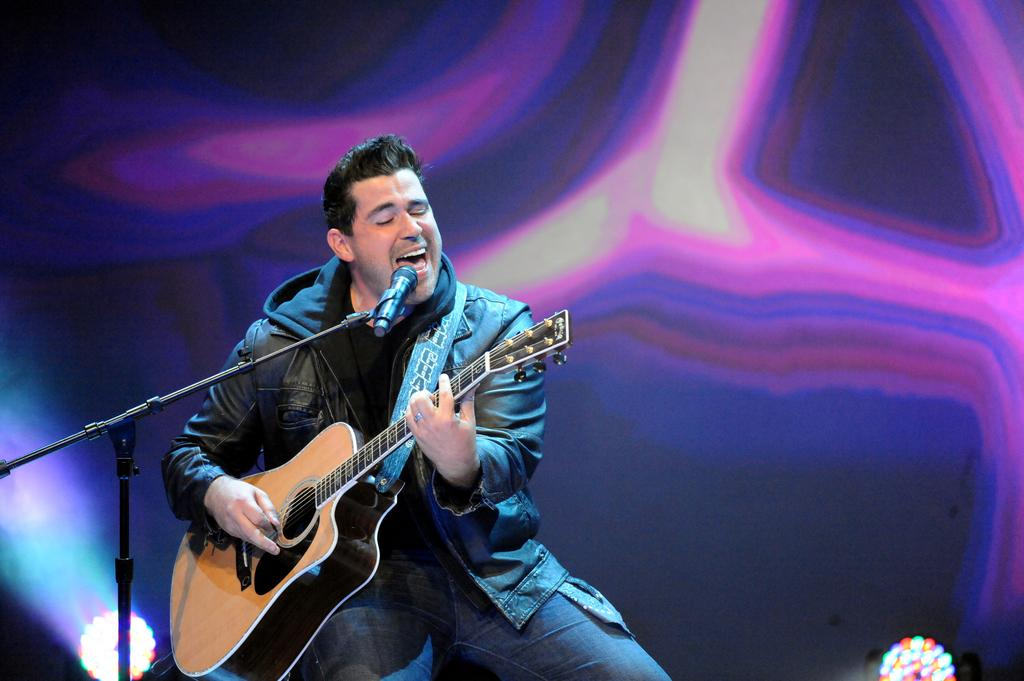Who is the main subject in the image? There is a man in the image. What is the man doing in the image? The man is sitting on a chair and holding a guitar. What object is in front of the man? There is a microphone with a stand in front of the man. What is the man wearing in the image? The man is wearing a black-colored jacket. How many boys are present in the image? There is no boy present in the image; it features a man. What type of sack is being used to deliver the baby in the image? There is no baby or sack present in the image; it features a man holding a guitar. 